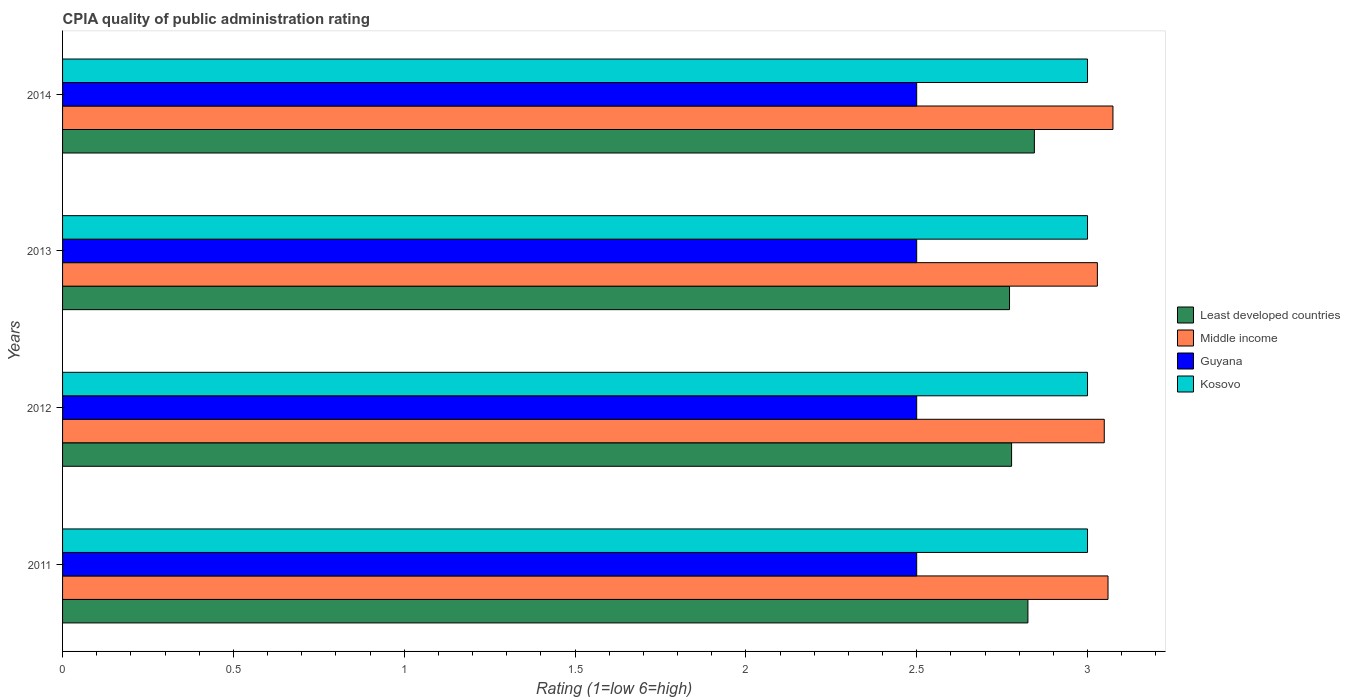How many groups of bars are there?
Offer a terse response. 4. Are the number of bars per tick equal to the number of legend labels?
Provide a succinct answer. Yes. What is the CPIA rating in Middle income in 2012?
Your response must be concise. 3.05. Across all years, what is the maximum CPIA rating in Least developed countries?
Your answer should be compact. 2.84. In which year was the CPIA rating in Least developed countries maximum?
Provide a succinct answer. 2014. What is the difference between the CPIA rating in Middle income in 2012 and that in 2014?
Offer a very short reply. -0.03. What is the difference between the CPIA rating in Middle income in 2011 and the CPIA rating in Guyana in 2013?
Offer a terse response. 0.56. What is the average CPIA rating in Least developed countries per year?
Offer a very short reply. 2.8. In the year 2014, what is the difference between the CPIA rating in Middle income and CPIA rating in Least developed countries?
Your response must be concise. 0.23. In how many years, is the CPIA rating in Guyana greater than 1.3 ?
Your answer should be compact. 4. Is the difference between the CPIA rating in Middle income in 2012 and 2014 greater than the difference between the CPIA rating in Least developed countries in 2012 and 2014?
Provide a short and direct response. Yes. What is the difference between the highest and the second highest CPIA rating in Guyana?
Provide a succinct answer. 0. What is the difference between the highest and the lowest CPIA rating in Middle income?
Provide a short and direct response. 0.05. Is it the case that in every year, the sum of the CPIA rating in Guyana and CPIA rating in Least developed countries is greater than the sum of CPIA rating in Kosovo and CPIA rating in Middle income?
Your answer should be very brief. No. What does the 2nd bar from the top in 2014 represents?
Make the answer very short. Guyana. What does the 3rd bar from the bottom in 2013 represents?
Offer a terse response. Guyana. Is it the case that in every year, the sum of the CPIA rating in Guyana and CPIA rating in Least developed countries is greater than the CPIA rating in Kosovo?
Your answer should be compact. Yes. How many years are there in the graph?
Provide a short and direct response. 4. Are the values on the major ticks of X-axis written in scientific E-notation?
Ensure brevity in your answer.  No. Does the graph contain any zero values?
Ensure brevity in your answer.  No. What is the title of the graph?
Provide a succinct answer. CPIA quality of public administration rating. Does "High income: OECD" appear as one of the legend labels in the graph?
Your response must be concise. No. What is the Rating (1=low 6=high) of Least developed countries in 2011?
Provide a succinct answer. 2.83. What is the Rating (1=low 6=high) in Middle income in 2011?
Provide a short and direct response. 3.06. What is the Rating (1=low 6=high) in Kosovo in 2011?
Provide a short and direct response. 3. What is the Rating (1=low 6=high) in Least developed countries in 2012?
Ensure brevity in your answer.  2.78. What is the Rating (1=low 6=high) in Middle income in 2012?
Ensure brevity in your answer.  3.05. What is the Rating (1=low 6=high) in Guyana in 2012?
Make the answer very short. 2.5. What is the Rating (1=low 6=high) of Least developed countries in 2013?
Offer a very short reply. 2.77. What is the Rating (1=low 6=high) in Middle income in 2013?
Your answer should be compact. 3.03. What is the Rating (1=low 6=high) of Kosovo in 2013?
Provide a succinct answer. 3. What is the Rating (1=low 6=high) in Least developed countries in 2014?
Offer a terse response. 2.84. What is the Rating (1=low 6=high) of Middle income in 2014?
Keep it short and to the point. 3.07. Across all years, what is the maximum Rating (1=low 6=high) in Least developed countries?
Provide a short and direct response. 2.84. Across all years, what is the maximum Rating (1=low 6=high) in Middle income?
Keep it short and to the point. 3.07. Across all years, what is the minimum Rating (1=low 6=high) of Least developed countries?
Provide a short and direct response. 2.77. Across all years, what is the minimum Rating (1=low 6=high) in Middle income?
Offer a very short reply. 3.03. Across all years, what is the minimum Rating (1=low 6=high) of Guyana?
Your answer should be very brief. 2.5. What is the total Rating (1=low 6=high) in Least developed countries in the graph?
Give a very brief answer. 11.22. What is the total Rating (1=low 6=high) in Middle income in the graph?
Your answer should be compact. 12.21. What is the total Rating (1=low 6=high) in Guyana in the graph?
Offer a very short reply. 10. What is the total Rating (1=low 6=high) in Kosovo in the graph?
Provide a succinct answer. 12. What is the difference between the Rating (1=low 6=high) of Least developed countries in 2011 and that in 2012?
Offer a very short reply. 0.05. What is the difference between the Rating (1=low 6=high) in Middle income in 2011 and that in 2012?
Provide a short and direct response. 0.01. What is the difference between the Rating (1=low 6=high) in Least developed countries in 2011 and that in 2013?
Offer a terse response. 0.05. What is the difference between the Rating (1=low 6=high) of Middle income in 2011 and that in 2013?
Your response must be concise. 0.03. What is the difference between the Rating (1=low 6=high) of Guyana in 2011 and that in 2013?
Ensure brevity in your answer.  0. What is the difference between the Rating (1=low 6=high) in Least developed countries in 2011 and that in 2014?
Offer a terse response. -0.02. What is the difference between the Rating (1=low 6=high) of Middle income in 2011 and that in 2014?
Your answer should be compact. -0.01. What is the difference between the Rating (1=low 6=high) of Guyana in 2011 and that in 2014?
Ensure brevity in your answer.  0. What is the difference between the Rating (1=low 6=high) in Least developed countries in 2012 and that in 2013?
Provide a succinct answer. 0.01. What is the difference between the Rating (1=low 6=high) of Middle income in 2012 and that in 2013?
Offer a very short reply. 0.02. What is the difference between the Rating (1=low 6=high) of Least developed countries in 2012 and that in 2014?
Ensure brevity in your answer.  -0.07. What is the difference between the Rating (1=low 6=high) of Middle income in 2012 and that in 2014?
Ensure brevity in your answer.  -0.03. What is the difference between the Rating (1=low 6=high) of Guyana in 2012 and that in 2014?
Your response must be concise. 0. What is the difference between the Rating (1=low 6=high) of Kosovo in 2012 and that in 2014?
Provide a succinct answer. 0. What is the difference between the Rating (1=low 6=high) in Least developed countries in 2013 and that in 2014?
Give a very brief answer. -0.07. What is the difference between the Rating (1=low 6=high) in Middle income in 2013 and that in 2014?
Your answer should be compact. -0.05. What is the difference between the Rating (1=low 6=high) in Kosovo in 2013 and that in 2014?
Provide a succinct answer. 0. What is the difference between the Rating (1=low 6=high) of Least developed countries in 2011 and the Rating (1=low 6=high) of Middle income in 2012?
Ensure brevity in your answer.  -0.22. What is the difference between the Rating (1=low 6=high) of Least developed countries in 2011 and the Rating (1=low 6=high) of Guyana in 2012?
Offer a terse response. 0.33. What is the difference between the Rating (1=low 6=high) in Least developed countries in 2011 and the Rating (1=low 6=high) in Kosovo in 2012?
Offer a very short reply. -0.17. What is the difference between the Rating (1=low 6=high) in Middle income in 2011 and the Rating (1=low 6=high) in Guyana in 2012?
Keep it short and to the point. 0.56. What is the difference between the Rating (1=low 6=high) in Middle income in 2011 and the Rating (1=low 6=high) in Kosovo in 2012?
Keep it short and to the point. 0.06. What is the difference between the Rating (1=low 6=high) of Guyana in 2011 and the Rating (1=low 6=high) of Kosovo in 2012?
Provide a short and direct response. -0.5. What is the difference between the Rating (1=low 6=high) of Least developed countries in 2011 and the Rating (1=low 6=high) of Middle income in 2013?
Offer a terse response. -0.2. What is the difference between the Rating (1=low 6=high) in Least developed countries in 2011 and the Rating (1=low 6=high) in Guyana in 2013?
Your response must be concise. 0.33. What is the difference between the Rating (1=low 6=high) of Least developed countries in 2011 and the Rating (1=low 6=high) of Kosovo in 2013?
Make the answer very short. -0.17. What is the difference between the Rating (1=low 6=high) of Middle income in 2011 and the Rating (1=low 6=high) of Guyana in 2013?
Offer a terse response. 0.56. What is the difference between the Rating (1=low 6=high) in Least developed countries in 2011 and the Rating (1=low 6=high) in Middle income in 2014?
Keep it short and to the point. -0.25. What is the difference between the Rating (1=low 6=high) of Least developed countries in 2011 and the Rating (1=low 6=high) of Guyana in 2014?
Provide a succinct answer. 0.33. What is the difference between the Rating (1=low 6=high) of Least developed countries in 2011 and the Rating (1=low 6=high) of Kosovo in 2014?
Offer a terse response. -0.17. What is the difference between the Rating (1=low 6=high) of Middle income in 2011 and the Rating (1=low 6=high) of Guyana in 2014?
Your answer should be very brief. 0.56. What is the difference between the Rating (1=low 6=high) in Least developed countries in 2012 and the Rating (1=low 6=high) in Middle income in 2013?
Provide a succinct answer. -0.25. What is the difference between the Rating (1=low 6=high) of Least developed countries in 2012 and the Rating (1=low 6=high) of Guyana in 2013?
Offer a very short reply. 0.28. What is the difference between the Rating (1=low 6=high) of Least developed countries in 2012 and the Rating (1=low 6=high) of Kosovo in 2013?
Offer a very short reply. -0.22. What is the difference between the Rating (1=low 6=high) in Middle income in 2012 and the Rating (1=low 6=high) in Guyana in 2013?
Provide a succinct answer. 0.55. What is the difference between the Rating (1=low 6=high) in Middle income in 2012 and the Rating (1=low 6=high) in Kosovo in 2013?
Offer a terse response. 0.05. What is the difference between the Rating (1=low 6=high) in Guyana in 2012 and the Rating (1=low 6=high) in Kosovo in 2013?
Provide a short and direct response. -0.5. What is the difference between the Rating (1=low 6=high) in Least developed countries in 2012 and the Rating (1=low 6=high) in Middle income in 2014?
Provide a succinct answer. -0.3. What is the difference between the Rating (1=low 6=high) of Least developed countries in 2012 and the Rating (1=low 6=high) of Guyana in 2014?
Keep it short and to the point. 0.28. What is the difference between the Rating (1=low 6=high) in Least developed countries in 2012 and the Rating (1=low 6=high) in Kosovo in 2014?
Keep it short and to the point. -0.22. What is the difference between the Rating (1=low 6=high) in Middle income in 2012 and the Rating (1=low 6=high) in Guyana in 2014?
Your response must be concise. 0.55. What is the difference between the Rating (1=low 6=high) of Middle income in 2012 and the Rating (1=low 6=high) of Kosovo in 2014?
Ensure brevity in your answer.  0.05. What is the difference between the Rating (1=low 6=high) in Guyana in 2012 and the Rating (1=low 6=high) in Kosovo in 2014?
Offer a terse response. -0.5. What is the difference between the Rating (1=low 6=high) in Least developed countries in 2013 and the Rating (1=low 6=high) in Middle income in 2014?
Your response must be concise. -0.3. What is the difference between the Rating (1=low 6=high) in Least developed countries in 2013 and the Rating (1=low 6=high) in Guyana in 2014?
Provide a succinct answer. 0.27. What is the difference between the Rating (1=low 6=high) of Least developed countries in 2013 and the Rating (1=low 6=high) of Kosovo in 2014?
Give a very brief answer. -0.23. What is the difference between the Rating (1=low 6=high) in Middle income in 2013 and the Rating (1=low 6=high) in Guyana in 2014?
Your answer should be compact. 0.53. What is the difference between the Rating (1=low 6=high) in Middle income in 2013 and the Rating (1=low 6=high) in Kosovo in 2014?
Make the answer very short. 0.03. What is the difference between the Rating (1=low 6=high) in Guyana in 2013 and the Rating (1=low 6=high) in Kosovo in 2014?
Give a very brief answer. -0.5. What is the average Rating (1=low 6=high) in Least developed countries per year?
Give a very brief answer. 2.8. What is the average Rating (1=low 6=high) of Middle income per year?
Your response must be concise. 3.05. What is the average Rating (1=low 6=high) of Guyana per year?
Offer a terse response. 2.5. In the year 2011, what is the difference between the Rating (1=low 6=high) of Least developed countries and Rating (1=low 6=high) of Middle income?
Ensure brevity in your answer.  -0.23. In the year 2011, what is the difference between the Rating (1=low 6=high) of Least developed countries and Rating (1=low 6=high) of Guyana?
Your answer should be very brief. 0.33. In the year 2011, what is the difference between the Rating (1=low 6=high) in Least developed countries and Rating (1=low 6=high) in Kosovo?
Provide a succinct answer. -0.17. In the year 2011, what is the difference between the Rating (1=low 6=high) of Middle income and Rating (1=low 6=high) of Guyana?
Provide a short and direct response. 0.56. In the year 2011, what is the difference between the Rating (1=low 6=high) of Guyana and Rating (1=low 6=high) of Kosovo?
Provide a short and direct response. -0.5. In the year 2012, what is the difference between the Rating (1=low 6=high) in Least developed countries and Rating (1=low 6=high) in Middle income?
Keep it short and to the point. -0.27. In the year 2012, what is the difference between the Rating (1=low 6=high) in Least developed countries and Rating (1=low 6=high) in Guyana?
Offer a terse response. 0.28. In the year 2012, what is the difference between the Rating (1=low 6=high) in Least developed countries and Rating (1=low 6=high) in Kosovo?
Your response must be concise. -0.22. In the year 2012, what is the difference between the Rating (1=low 6=high) of Middle income and Rating (1=low 6=high) of Guyana?
Offer a very short reply. 0.55. In the year 2012, what is the difference between the Rating (1=low 6=high) in Middle income and Rating (1=low 6=high) in Kosovo?
Your answer should be very brief. 0.05. In the year 2012, what is the difference between the Rating (1=low 6=high) in Guyana and Rating (1=low 6=high) in Kosovo?
Ensure brevity in your answer.  -0.5. In the year 2013, what is the difference between the Rating (1=low 6=high) in Least developed countries and Rating (1=low 6=high) in Middle income?
Offer a terse response. -0.26. In the year 2013, what is the difference between the Rating (1=low 6=high) in Least developed countries and Rating (1=low 6=high) in Guyana?
Ensure brevity in your answer.  0.27. In the year 2013, what is the difference between the Rating (1=low 6=high) in Least developed countries and Rating (1=low 6=high) in Kosovo?
Ensure brevity in your answer.  -0.23. In the year 2013, what is the difference between the Rating (1=low 6=high) of Middle income and Rating (1=low 6=high) of Guyana?
Give a very brief answer. 0.53. In the year 2013, what is the difference between the Rating (1=low 6=high) of Middle income and Rating (1=low 6=high) of Kosovo?
Your answer should be very brief. 0.03. In the year 2014, what is the difference between the Rating (1=low 6=high) of Least developed countries and Rating (1=low 6=high) of Middle income?
Provide a succinct answer. -0.23. In the year 2014, what is the difference between the Rating (1=low 6=high) of Least developed countries and Rating (1=low 6=high) of Guyana?
Provide a short and direct response. 0.34. In the year 2014, what is the difference between the Rating (1=low 6=high) of Least developed countries and Rating (1=low 6=high) of Kosovo?
Give a very brief answer. -0.16. In the year 2014, what is the difference between the Rating (1=low 6=high) of Middle income and Rating (1=low 6=high) of Guyana?
Ensure brevity in your answer.  0.57. In the year 2014, what is the difference between the Rating (1=low 6=high) in Middle income and Rating (1=low 6=high) in Kosovo?
Offer a terse response. 0.07. In the year 2014, what is the difference between the Rating (1=low 6=high) in Guyana and Rating (1=low 6=high) in Kosovo?
Offer a terse response. -0.5. What is the ratio of the Rating (1=low 6=high) of Least developed countries in 2011 to that in 2012?
Offer a terse response. 1.02. What is the ratio of the Rating (1=low 6=high) in Least developed countries in 2011 to that in 2013?
Give a very brief answer. 1.02. What is the ratio of the Rating (1=low 6=high) of Middle income in 2011 to that in 2013?
Ensure brevity in your answer.  1.01. What is the ratio of the Rating (1=low 6=high) of Guyana in 2011 to that in 2013?
Give a very brief answer. 1. What is the ratio of the Rating (1=low 6=high) in Guyana in 2012 to that in 2013?
Provide a succinct answer. 1. What is the ratio of the Rating (1=low 6=high) of Kosovo in 2012 to that in 2013?
Offer a very short reply. 1. What is the ratio of the Rating (1=low 6=high) of Least developed countries in 2012 to that in 2014?
Offer a terse response. 0.98. What is the ratio of the Rating (1=low 6=high) of Middle income in 2012 to that in 2014?
Provide a succinct answer. 0.99. What is the ratio of the Rating (1=low 6=high) of Least developed countries in 2013 to that in 2014?
Your response must be concise. 0.97. What is the ratio of the Rating (1=low 6=high) in Middle income in 2013 to that in 2014?
Your response must be concise. 0.99. What is the ratio of the Rating (1=low 6=high) in Kosovo in 2013 to that in 2014?
Your answer should be very brief. 1. What is the difference between the highest and the second highest Rating (1=low 6=high) of Least developed countries?
Ensure brevity in your answer.  0.02. What is the difference between the highest and the second highest Rating (1=low 6=high) of Middle income?
Give a very brief answer. 0.01. What is the difference between the highest and the second highest Rating (1=low 6=high) of Guyana?
Your response must be concise. 0. What is the difference between the highest and the second highest Rating (1=low 6=high) of Kosovo?
Make the answer very short. 0. What is the difference between the highest and the lowest Rating (1=low 6=high) of Least developed countries?
Provide a succinct answer. 0.07. What is the difference between the highest and the lowest Rating (1=low 6=high) of Middle income?
Your answer should be compact. 0.05. What is the difference between the highest and the lowest Rating (1=low 6=high) in Guyana?
Your response must be concise. 0. What is the difference between the highest and the lowest Rating (1=low 6=high) in Kosovo?
Provide a short and direct response. 0. 